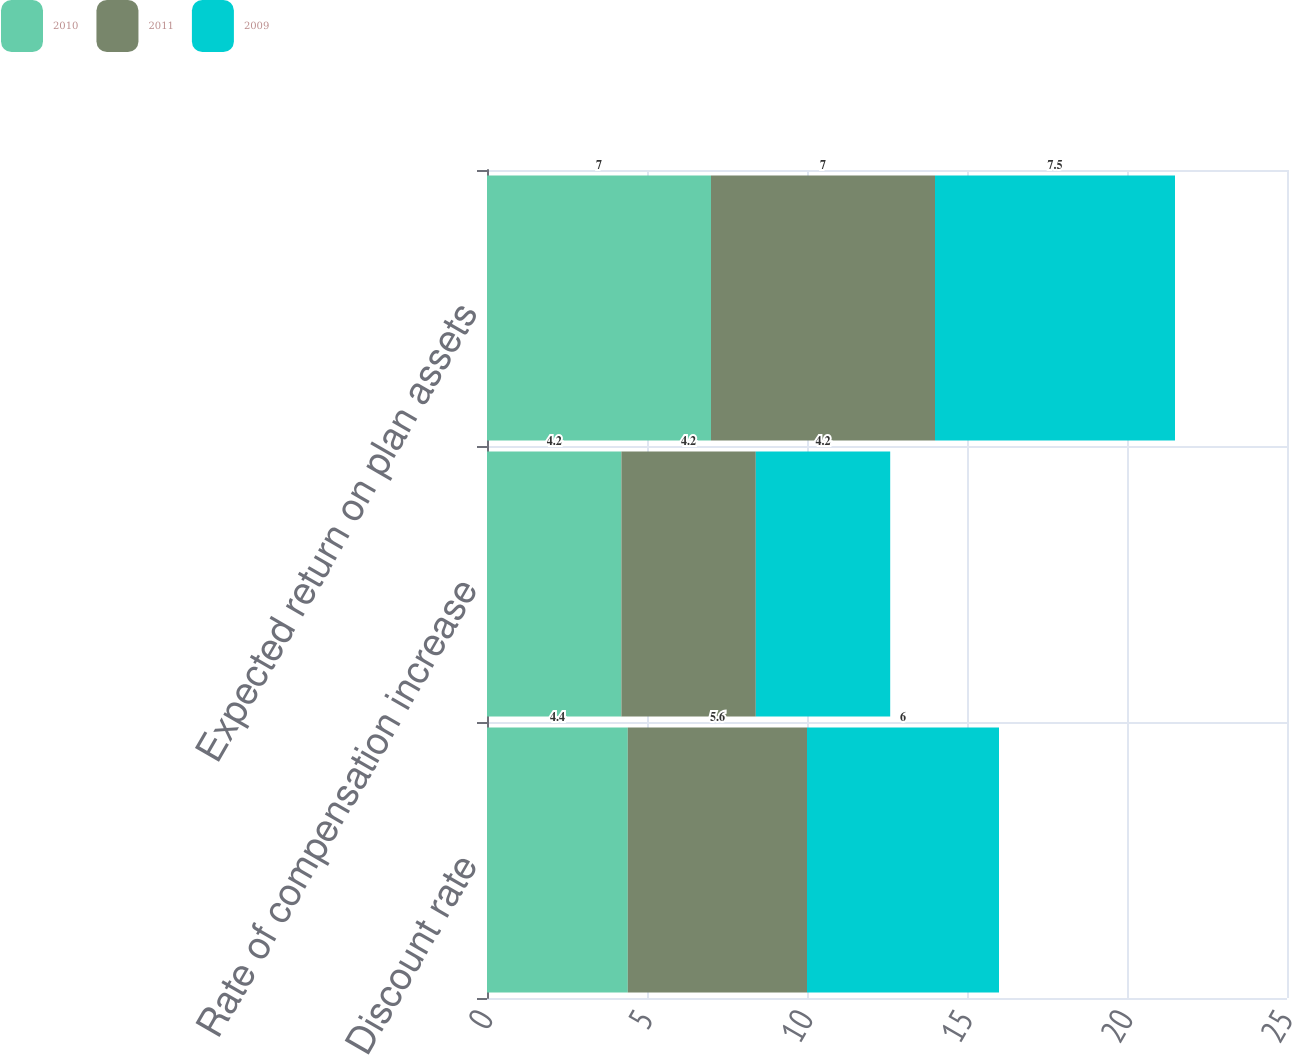Convert chart to OTSL. <chart><loc_0><loc_0><loc_500><loc_500><stacked_bar_chart><ecel><fcel>Discount rate<fcel>Rate of compensation increase<fcel>Expected return on plan assets<nl><fcel>2010<fcel>4.4<fcel>4.2<fcel>7<nl><fcel>2011<fcel>5.6<fcel>4.2<fcel>7<nl><fcel>2009<fcel>6<fcel>4.2<fcel>7.5<nl></chart> 